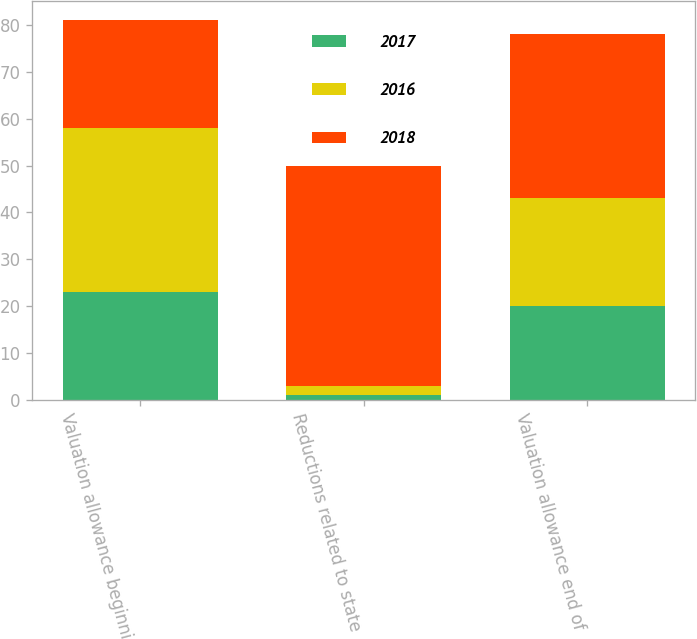<chart> <loc_0><loc_0><loc_500><loc_500><stacked_bar_chart><ecel><fcel>Valuation allowance beginning<fcel>Reductions related to state<fcel>Valuation allowance end of<nl><fcel>2017<fcel>23<fcel>1<fcel>20<nl><fcel>2016<fcel>35<fcel>2<fcel>23<nl><fcel>2018<fcel>23<fcel>47<fcel>35<nl></chart> 